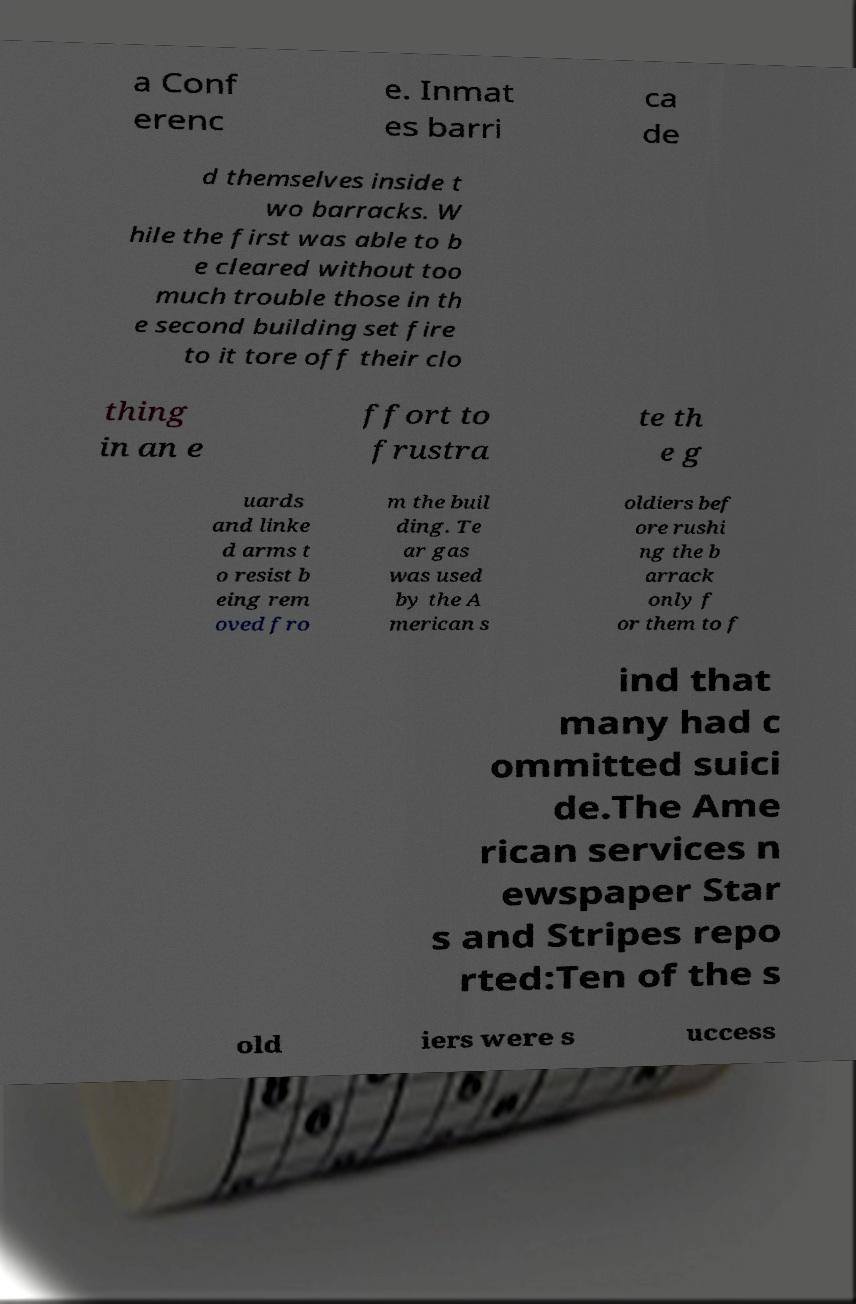There's text embedded in this image that I need extracted. Can you transcribe it verbatim? a Conf erenc e. Inmat es barri ca de d themselves inside t wo barracks. W hile the first was able to b e cleared without too much trouble those in th e second building set fire to it tore off their clo thing in an e ffort to frustra te th e g uards and linke d arms t o resist b eing rem oved fro m the buil ding. Te ar gas was used by the A merican s oldiers bef ore rushi ng the b arrack only f or them to f ind that many had c ommitted suici de.The Ame rican services n ewspaper Star s and Stripes repo rted:Ten of the s old iers were s uccess 